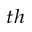Convert formula to latex. <formula><loc_0><loc_0><loc_500><loc_500>^ { t h }</formula> 